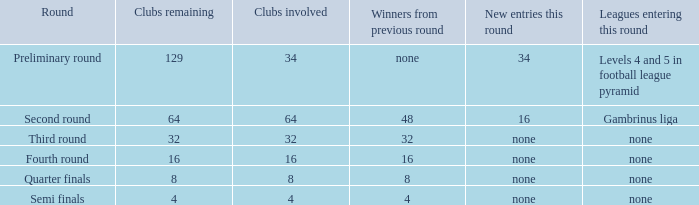Specify the leagues involved in this round for 4 None. 